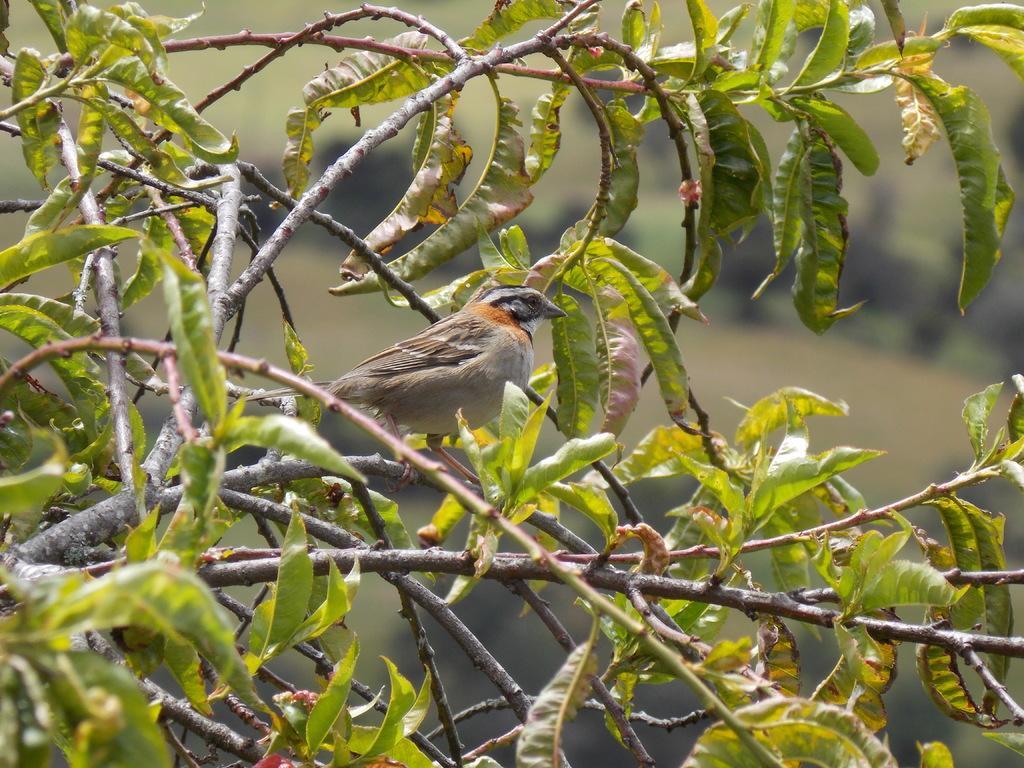How would you summarize this image in a sentence or two? In this picture we can see a bird and a tree and in the background we can see it is blurry. 